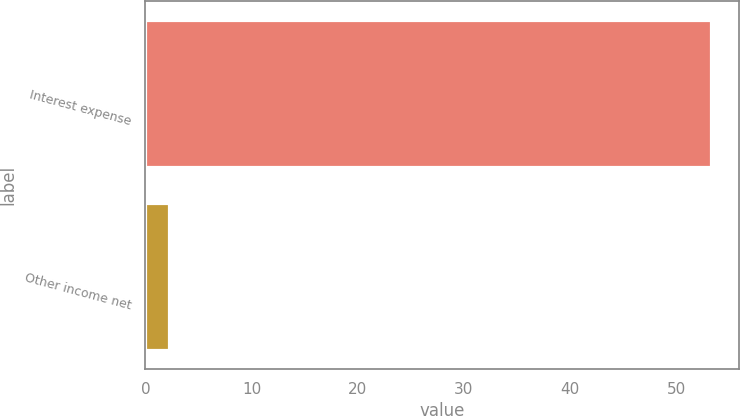Convert chart. <chart><loc_0><loc_0><loc_500><loc_500><bar_chart><fcel>Interest expense<fcel>Other income net<nl><fcel>53.3<fcel>2.2<nl></chart> 